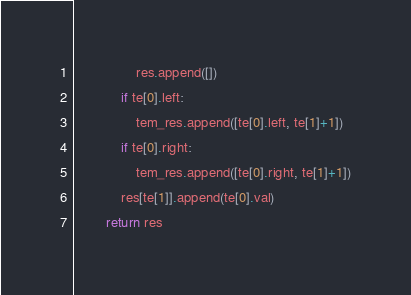<code> <loc_0><loc_0><loc_500><loc_500><_Python_>                res.append([])
            if te[0].left:
                tem_res.append([te[0].left, te[1]+1])
            if te[0].right:
                tem_res.append([te[0].right, te[1]+1])
            res[te[1]].append(te[0].val)
        return res


</code> 